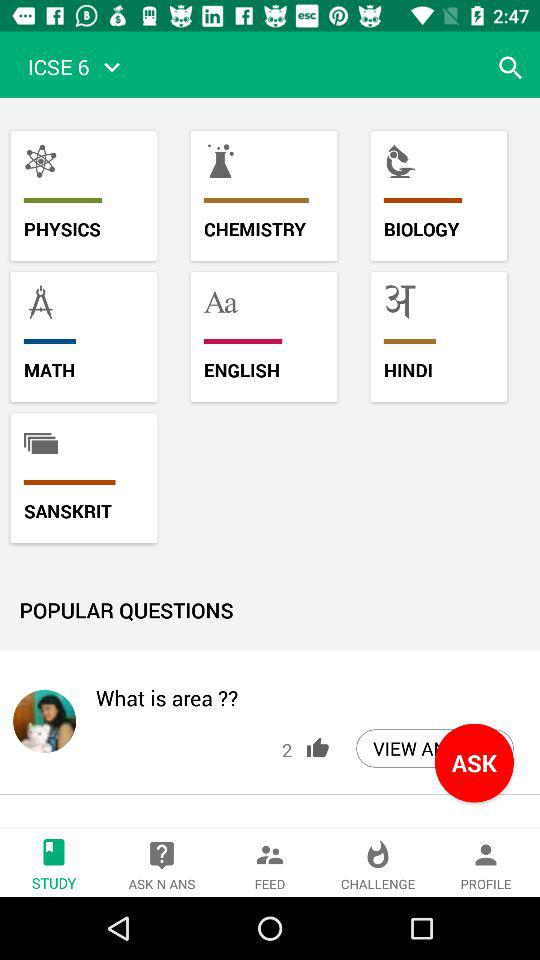How many likes are shown? The shown likes are 2. 